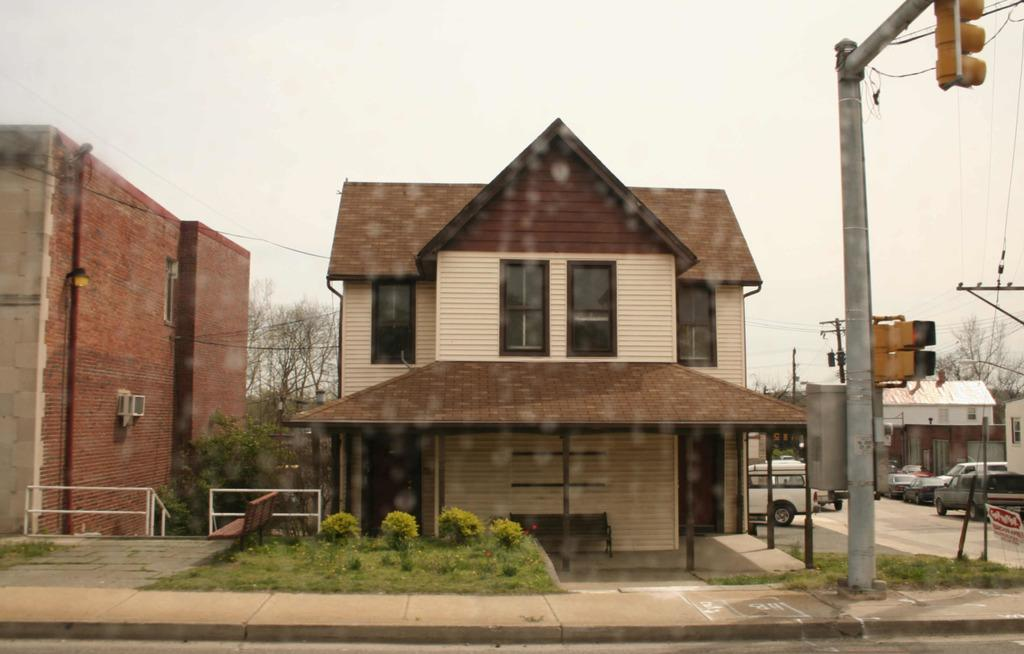What type of structures can be seen in the image? There are buildings in the image. What other natural elements are present in the image? There are trees and plants in the image. What is used to regulate traffic in the image? There is a traffic signal on a pole. What type of vehicles can be seen on the road? There are cars on the road. How would you describe the weather in the image? The sky is cloudy in the image. How many sheep are grazing in the image? There are no sheep present in the image. Can you describe the monkey playing with the traffic signal in the image? There is no monkey present in the image; the traffic signal is on a pole without any animals interacting with it. 